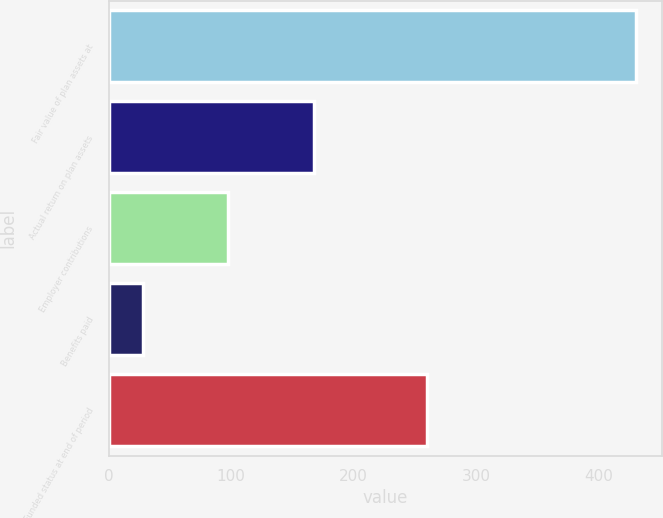Convert chart. <chart><loc_0><loc_0><loc_500><loc_500><bar_chart><fcel>Fair value of plan assets at<fcel>Actual return on plan assets<fcel>Employer contributions<fcel>Benefits paid<fcel>Funded status at end of period<nl><fcel>430<fcel>167.2<fcel>97.6<fcel>28<fcel>260<nl></chart> 